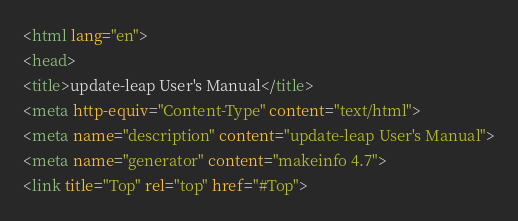Convert code to text. <code><loc_0><loc_0><loc_500><loc_500><_HTML_><html lang="en">
<head>
<title>update-leap User's Manual</title>
<meta http-equiv="Content-Type" content="text/html">
<meta name="description" content="update-leap User's Manual">
<meta name="generator" content="makeinfo 4.7">
<link title="Top" rel="top" href="#Top"></code> 